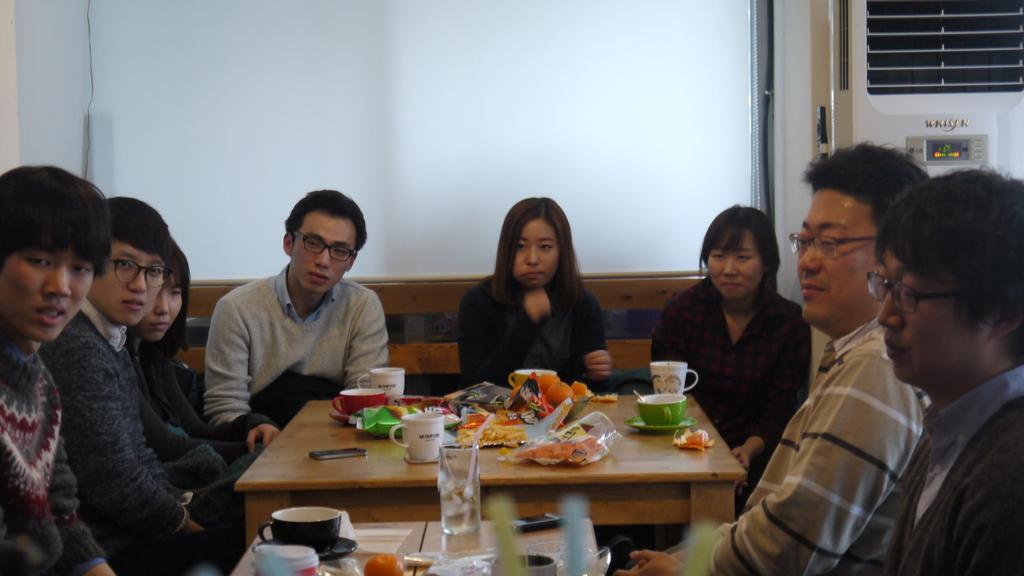Please provide a concise description of this image. There are many people sitting around a table. Person wearing a gray shirt is wearing a specs. On the table there is a mobile, cup, saucer, wrappers, covers, glasses and many other items. In the background there is a screen also there is a cooler. 